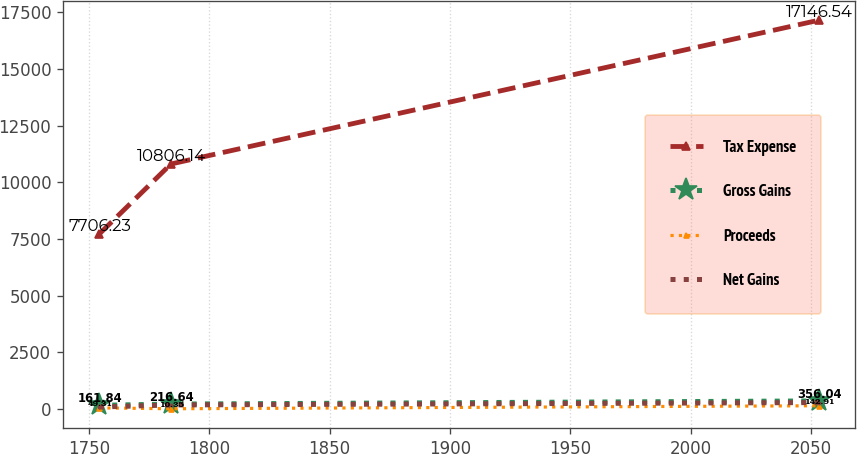Convert chart. <chart><loc_0><loc_0><loc_500><loc_500><line_chart><ecel><fcel>Tax Expense<fcel>Gross Gains<fcel>Proceeds<fcel>Net Gains<nl><fcel>1754.24<fcel>7706.23<fcel>161.84<fcel>49.31<fcel>86.44<nl><fcel>1784.12<fcel>10806.1<fcel>216.64<fcel>10.35<fcel>178.08<nl><fcel>2053.07<fcel>17146.5<fcel>356.04<fcel>142.91<fcel>283.52<nl></chart> 